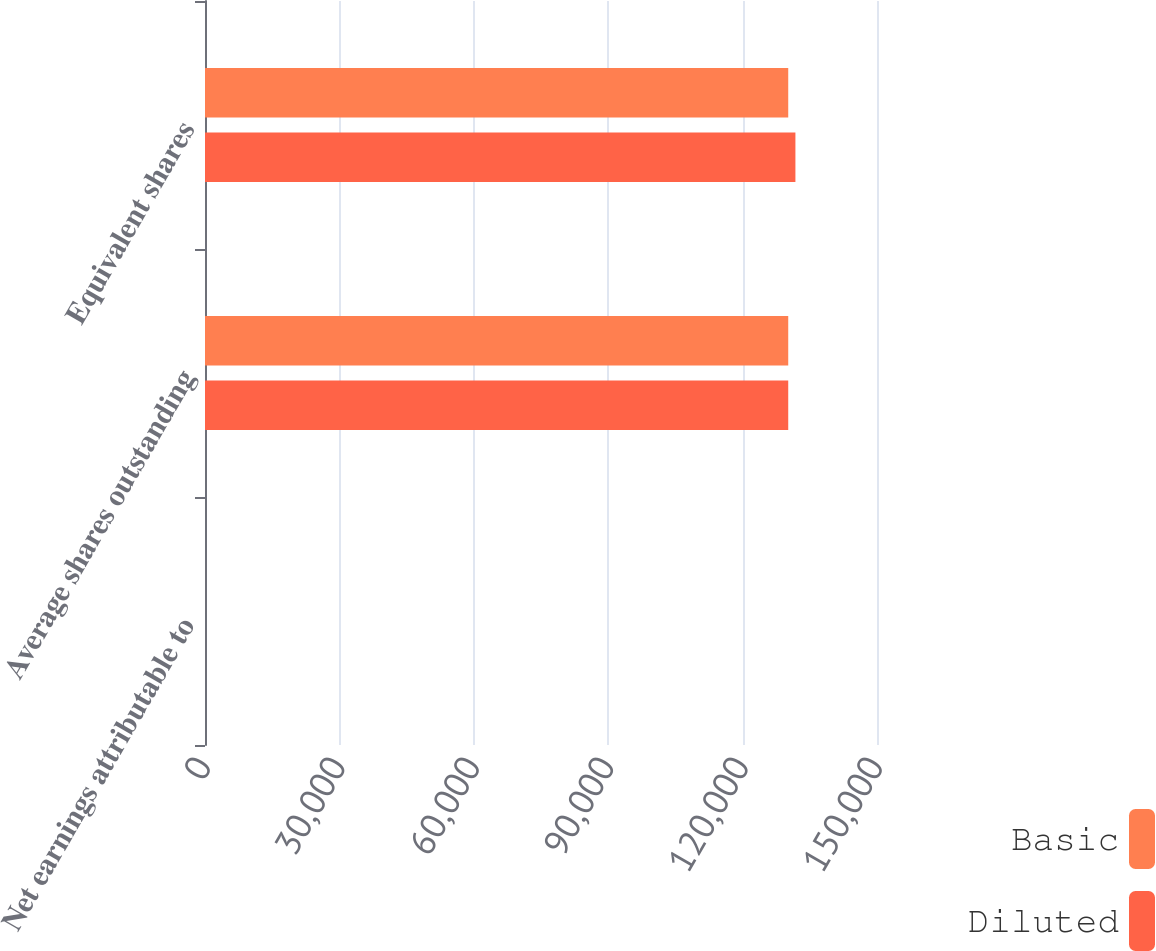<chart> <loc_0><loc_0><loc_500><loc_500><stacked_bar_chart><ecel><fcel>Net earnings attributable to<fcel>Average shares outstanding<fcel>Equivalent shares<nl><fcel>Basic<fcel>2.2<fcel>130186<fcel>130186<nl><fcel>Diluted<fcel>2.17<fcel>130186<fcel>131788<nl></chart> 